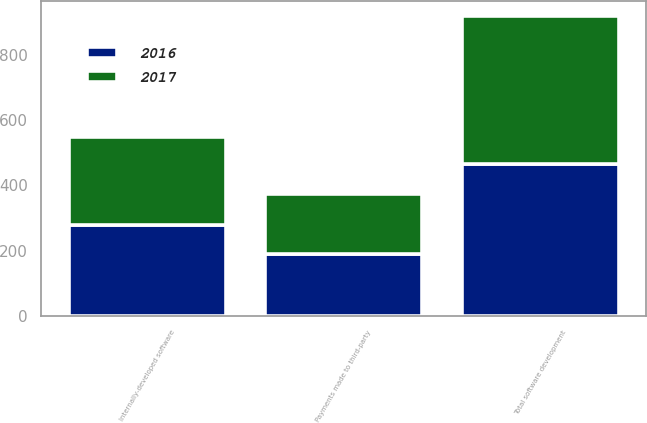<chart> <loc_0><loc_0><loc_500><loc_500><stacked_bar_chart><ecel><fcel>Internally-developed software<fcel>Payments made to third-party<fcel>Total software development<nl><fcel>2017<fcel>270<fcel>183<fcel>453<nl><fcel>2016<fcel>277<fcel>189<fcel>466<nl></chart> 